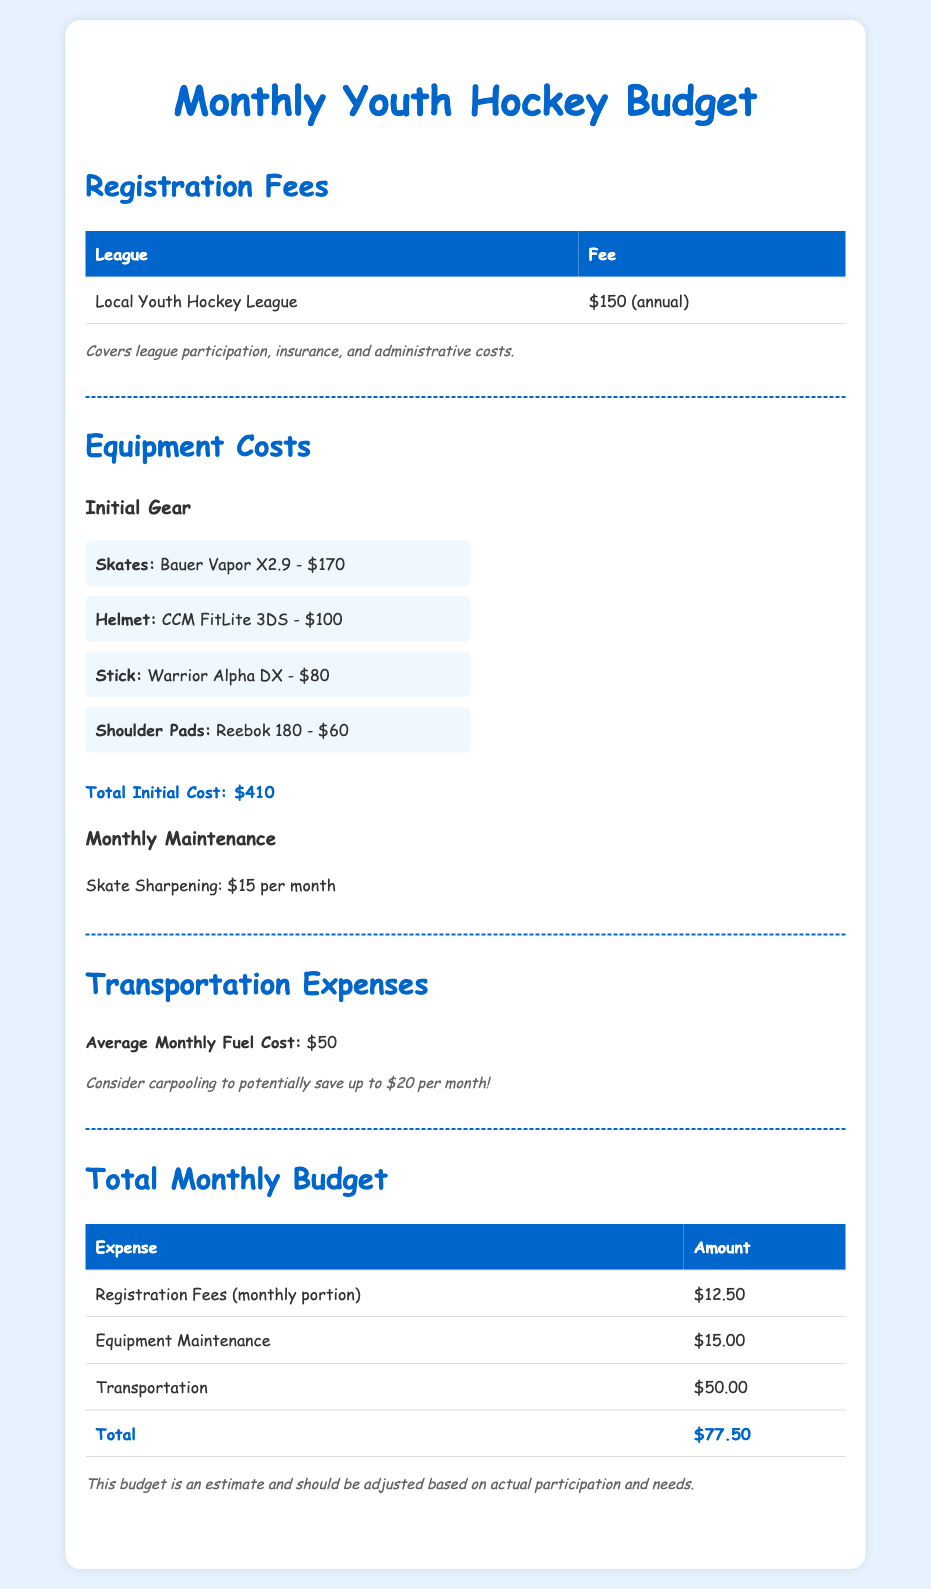what is the registration fee for the Local Youth Hockey League? The document states that the registration fee for the Local Youth Hockey League is $150 annually.
Answer: $150 (annual) how much does skate sharpening cost monthly? The document lists that skate sharpening costs $15 per month.
Answer: $15 per month what is the total initial cost for equipment? The total initial cost for all listed equipment is summarized in the document as $410.
Answer: $410 what is the average monthly fuel cost for transportation? The budget outlines that the average monthly fuel cost is $50.
Answer: $50 what is the total monthly budget for youth hockey participation? The document totals the monthly costs, stating the total is $77.50.
Answer: $77.50 how much can you potentially save by carpooling? The note in the transportation expenses section mentions that carpooling could save up to $20 per month.
Answer: $20 what is included in the registration fees? The note explains that the registration fees cover league participation, insurance, and administrative costs.
Answer: league participation, insurance, and administrative costs how many different types of initial gear are listed? The document lists four different types of initial gear for youth hockey participation.
Answer: four what color is the background of the budget document? The background color is described as light blue in the styling of the document.
Answer: light blue 